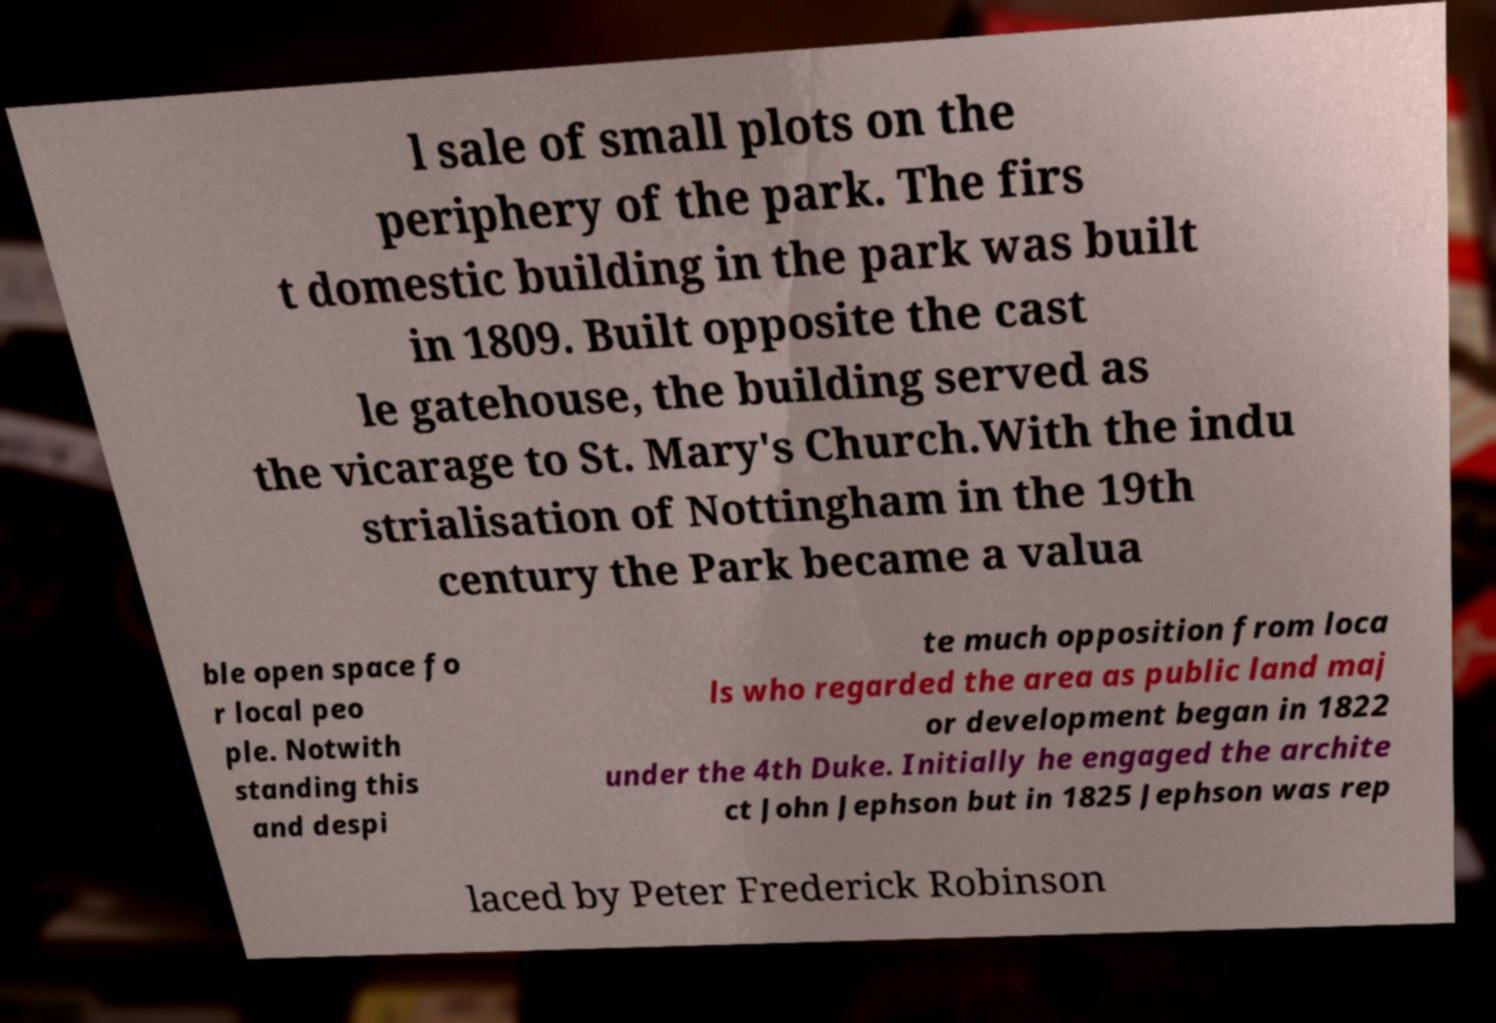Please read and relay the text visible in this image. What does it say? l sale of small plots on the periphery of the park. The firs t domestic building in the park was built in 1809. Built opposite the cast le gatehouse, the building served as the vicarage to St. Mary's Church.With the indu strialisation of Nottingham in the 19th century the Park became a valua ble open space fo r local peo ple. Notwith standing this and despi te much opposition from loca ls who regarded the area as public land maj or development began in 1822 under the 4th Duke. Initially he engaged the archite ct John Jephson but in 1825 Jephson was rep laced by Peter Frederick Robinson 